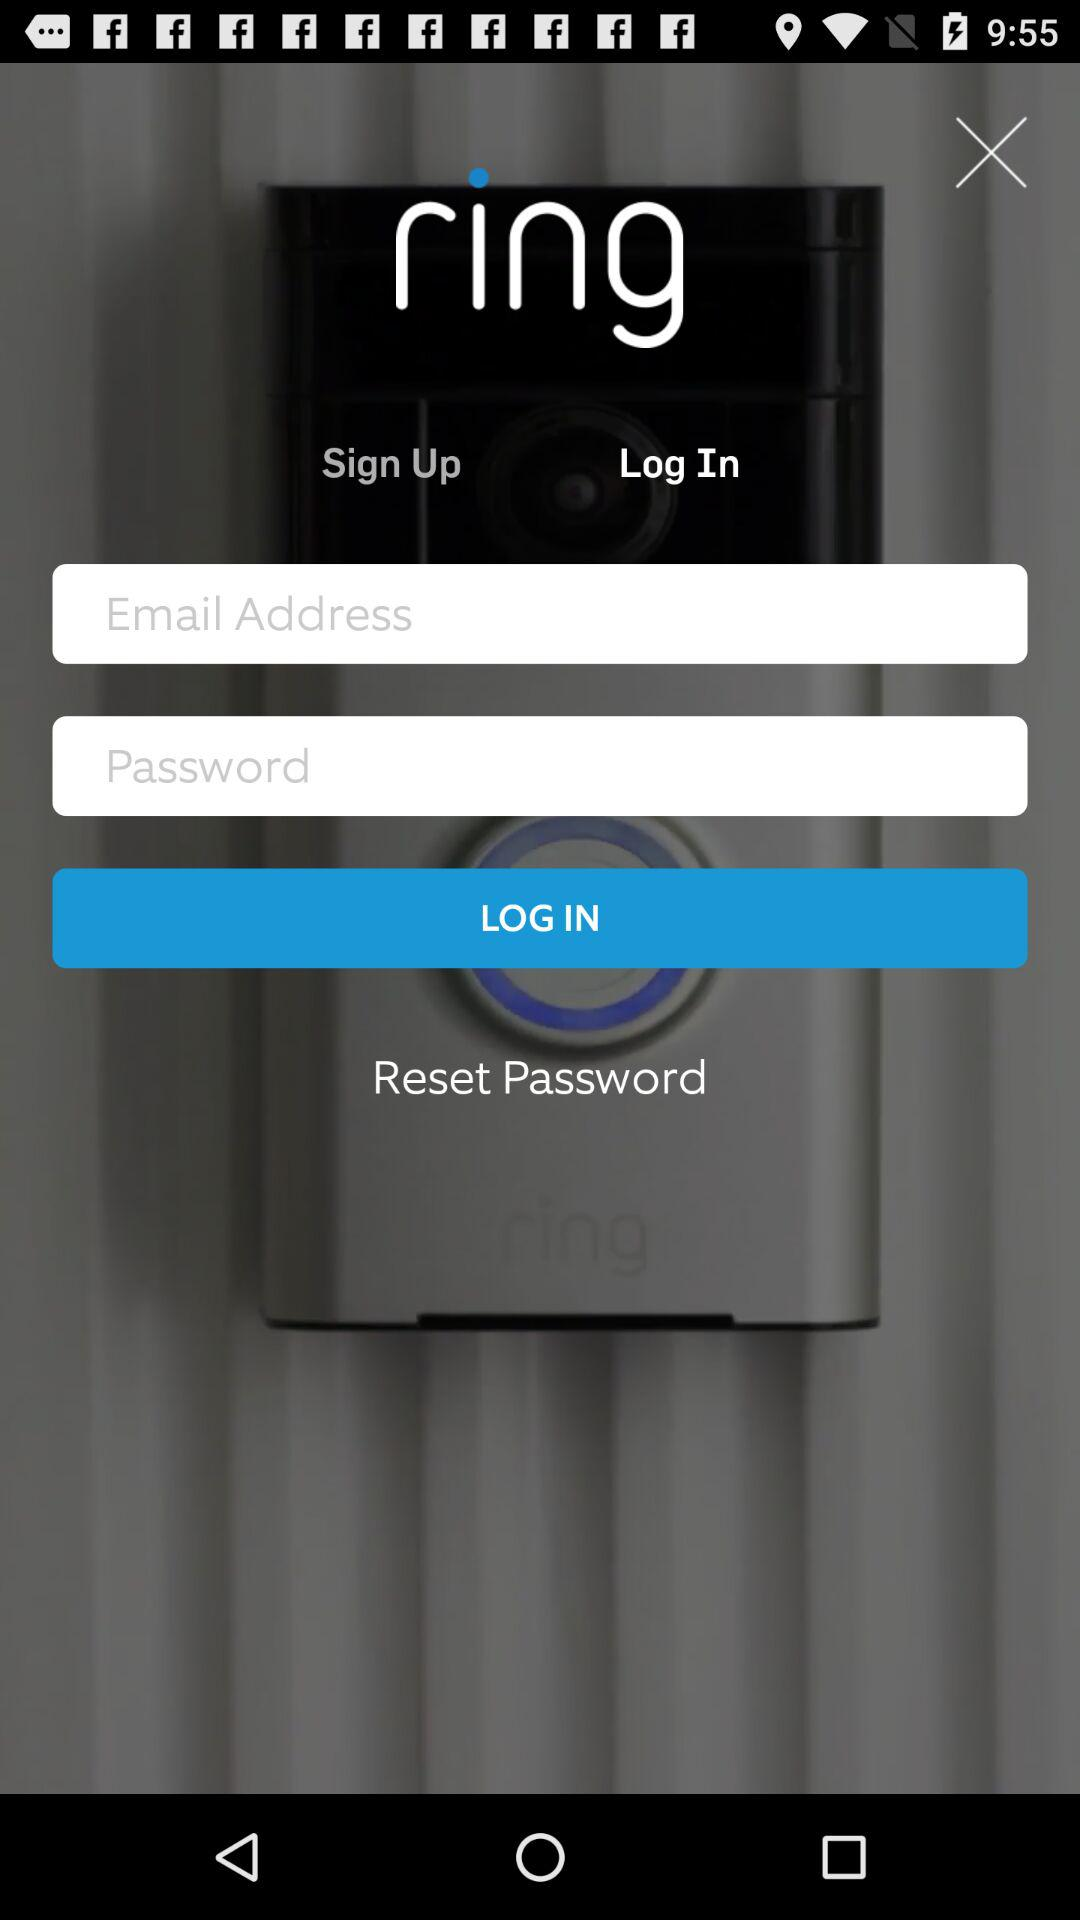What is the application name? The application name is "ring". 